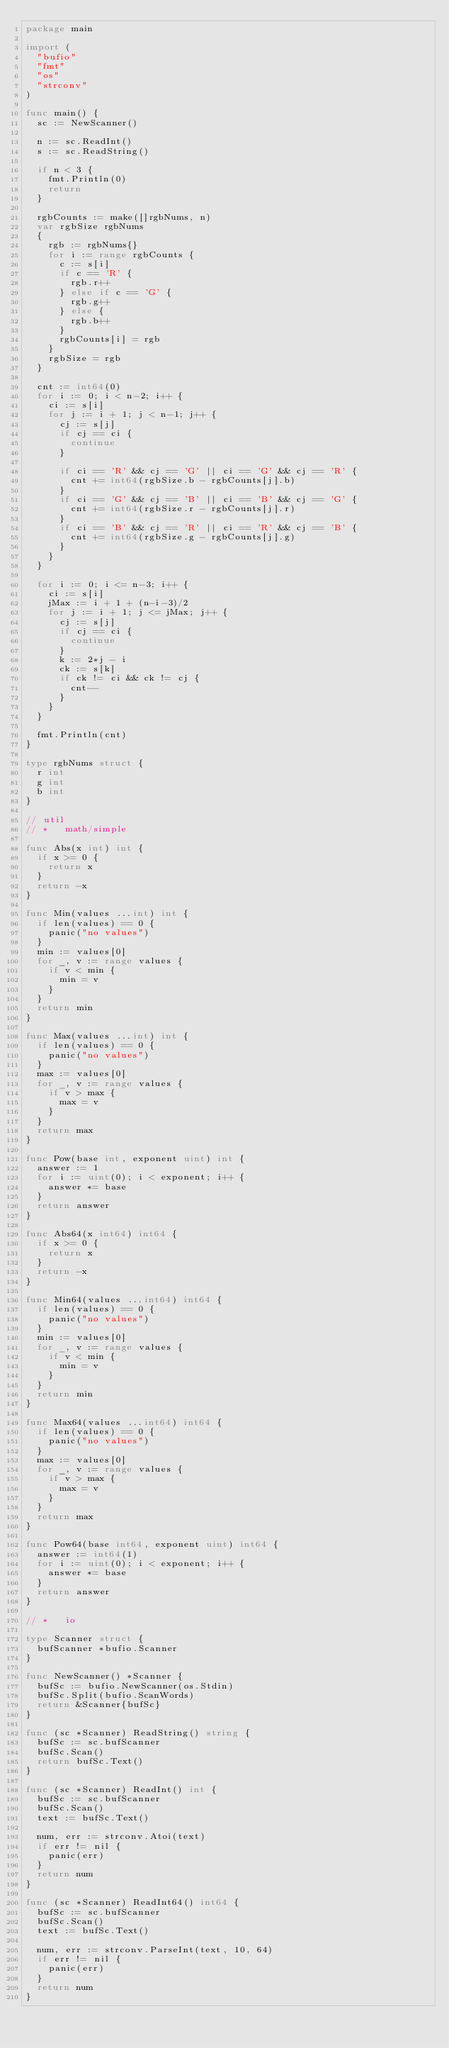<code> <loc_0><loc_0><loc_500><loc_500><_Go_>package main

import (
	"bufio"
	"fmt"
	"os"
	"strconv"
)

func main() {
	sc := NewScanner()

	n := sc.ReadInt()
	s := sc.ReadString()

	if n < 3 {
		fmt.Println(0)
		return
	}

	rgbCounts := make([]rgbNums, n)
	var rgbSize rgbNums
	{
		rgb := rgbNums{}
		for i := range rgbCounts {
			c := s[i]
			if c == 'R' {
				rgb.r++
			} else if c == 'G' {
				rgb.g++
			} else {
				rgb.b++
			}
			rgbCounts[i] = rgb
		}
		rgbSize = rgb
	}

	cnt := int64(0)
	for i := 0; i < n-2; i++ {
		ci := s[i]
		for j := i + 1; j < n-1; j++ {
			cj := s[j]
			if cj == ci {
				continue
			}

			if ci == 'R' && cj == 'G' || ci == 'G' && cj == 'R' {
				cnt += int64(rgbSize.b - rgbCounts[j].b)
			}
			if ci == 'G' && cj == 'B' || ci == 'B' && cj == 'G' {
				cnt += int64(rgbSize.r - rgbCounts[j].r)
			}
			if ci == 'B' && cj == 'R' || ci == 'R' && cj == 'B' {
				cnt += int64(rgbSize.g - rgbCounts[j].g)
			}
		}
	}

	for i := 0; i <= n-3; i++ {
		ci := s[i]
		jMax := i + 1 + (n-i-3)/2
		for j := i + 1; j <= jMax; j++ {
			cj := s[j]
			if cj == ci {
				continue
			}
			k := 2*j - i
			ck := s[k]
			if ck != ci && ck != cj {
				cnt--
			}
		}
	}

	fmt.Println(cnt)
}

type rgbNums struct {
	r int
	g int
	b int
}

// util
// *   math/simple

func Abs(x int) int {
	if x >= 0 {
		return x
	}
	return -x
}

func Min(values ...int) int {
	if len(values) == 0 {
		panic("no values")
	}
	min := values[0]
	for _, v := range values {
		if v < min {
			min = v
		}
	}
	return min
}

func Max(values ...int) int {
	if len(values) == 0 {
		panic("no values")
	}
	max := values[0]
	for _, v := range values {
		if v > max {
			max = v
		}
	}
	return max
}

func Pow(base int, exponent uint) int {
	answer := 1
	for i := uint(0); i < exponent; i++ {
		answer *= base
	}
	return answer
}

func Abs64(x int64) int64 {
	if x >= 0 {
		return x
	}
	return -x
}

func Min64(values ...int64) int64 {
	if len(values) == 0 {
		panic("no values")
	}
	min := values[0]
	for _, v := range values {
		if v < min {
			min = v
		}
	}
	return min
}

func Max64(values ...int64) int64 {
	if len(values) == 0 {
		panic("no values")
	}
	max := values[0]
	for _, v := range values {
		if v > max {
			max = v
		}
	}
	return max
}

func Pow64(base int64, exponent uint) int64 {
	answer := int64(1)
	for i := uint(0); i < exponent; i++ {
		answer *= base
	}
	return answer
}

// *   io

type Scanner struct {
	bufScanner *bufio.Scanner
}

func NewScanner() *Scanner {
	bufSc := bufio.NewScanner(os.Stdin)
	bufSc.Split(bufio.ScanWords)
	return &Scanner{bufSc}
}

func (sc *Scanner) ReadString() string {
	bufSc := sc.bufScanner
	bufSc.Scan()
	return bufSc.Text()
}

func (sc *Scanner) ReadInt() int {
	bufSc := sc.bufScanner
	bufSc.Scan()
	text := bufSc.Text()

	num, err := strconv.Atoi(text)
	if err != nil {
		panic(err)
	}
	return num
}

func (sc *Scanner) ReadInt64() int64 {
	bufSc := sc.bufScanner
	bufSc.Scan()
	text := bufSc.Text()

	num, err := strconv.ParseInt(text, 10, 64)
	if err != nil {
		panic(err)
	}
	return num
}
</code> 